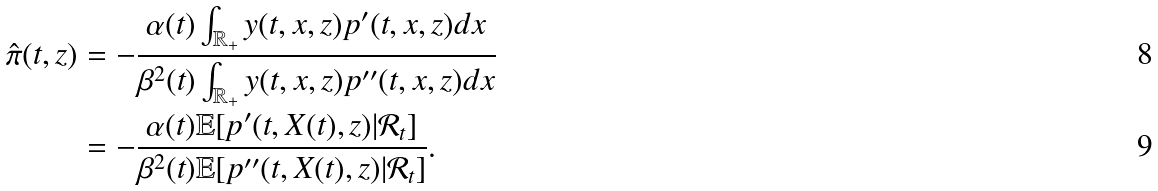Convert formula to latex. <formula><loc_0><loc_0><loc_500><loc_500>\hat { \pi } ( t , z ) & = - \frac { \alpha ( t ) \int _ { \mathbb { R } _ { + } } y ( t , x , z ) p ^ { \prime } ( t , x , z ) d x } { \beta ^ { 2 } ( t ) \int _ { \mathbb { R } _ { + } } y ( t , x , z ) p ^ { \prime \prime } ( t , x , z ) d x } \\ & = - \frac { \alpha ( t ) \mathbb { E } [ p ^ { \prime } ( t , X ( t ) , z ) | \mathcal { R } _ { t } ] } { \beta ^ { 2 } ( t ) \mathbb { E } [ p ^ { \prime \prime } ( t , X ( t ) , z ) | \mathcal { R } _ { t } ] } .</formula> 